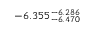Convert formula to latex. <formula><loc_0><loc_0><loc_500><loc_500>- 6 . 3 5 5 _ { - 6 . 4 7 0 } ^ { - 6 . 2 8 6 }</formula> 